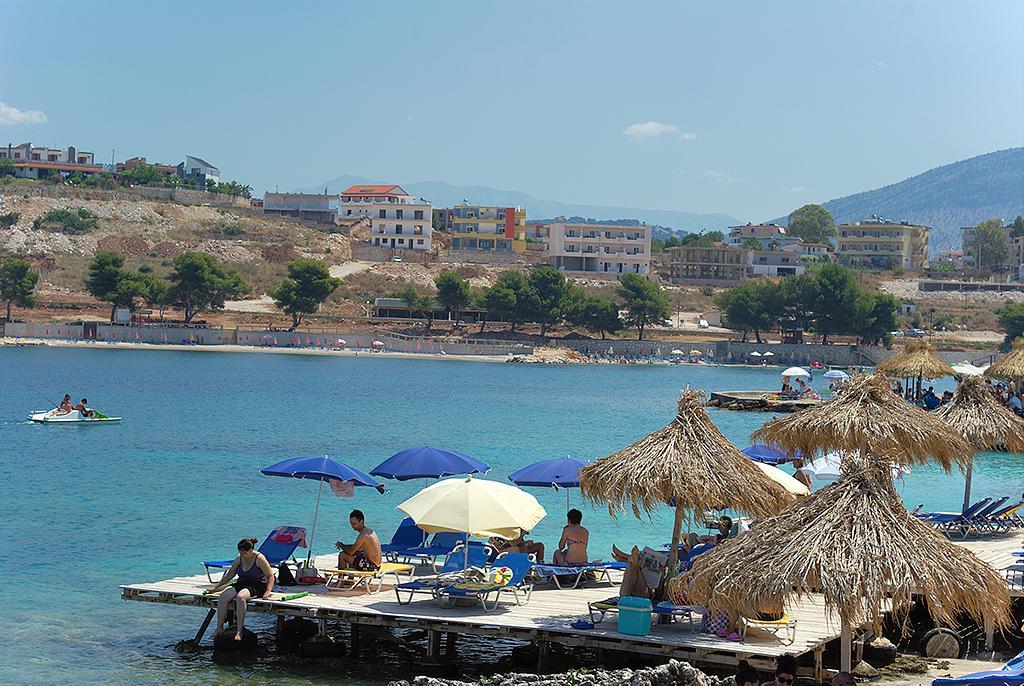Describe this image in one or two sentences. In this image we can see some persons sitting and lying on beach benches which are under umbrellas we can see some boats moving on water and in the background of the image there are some trees, buildings, mountains and clear sky. 